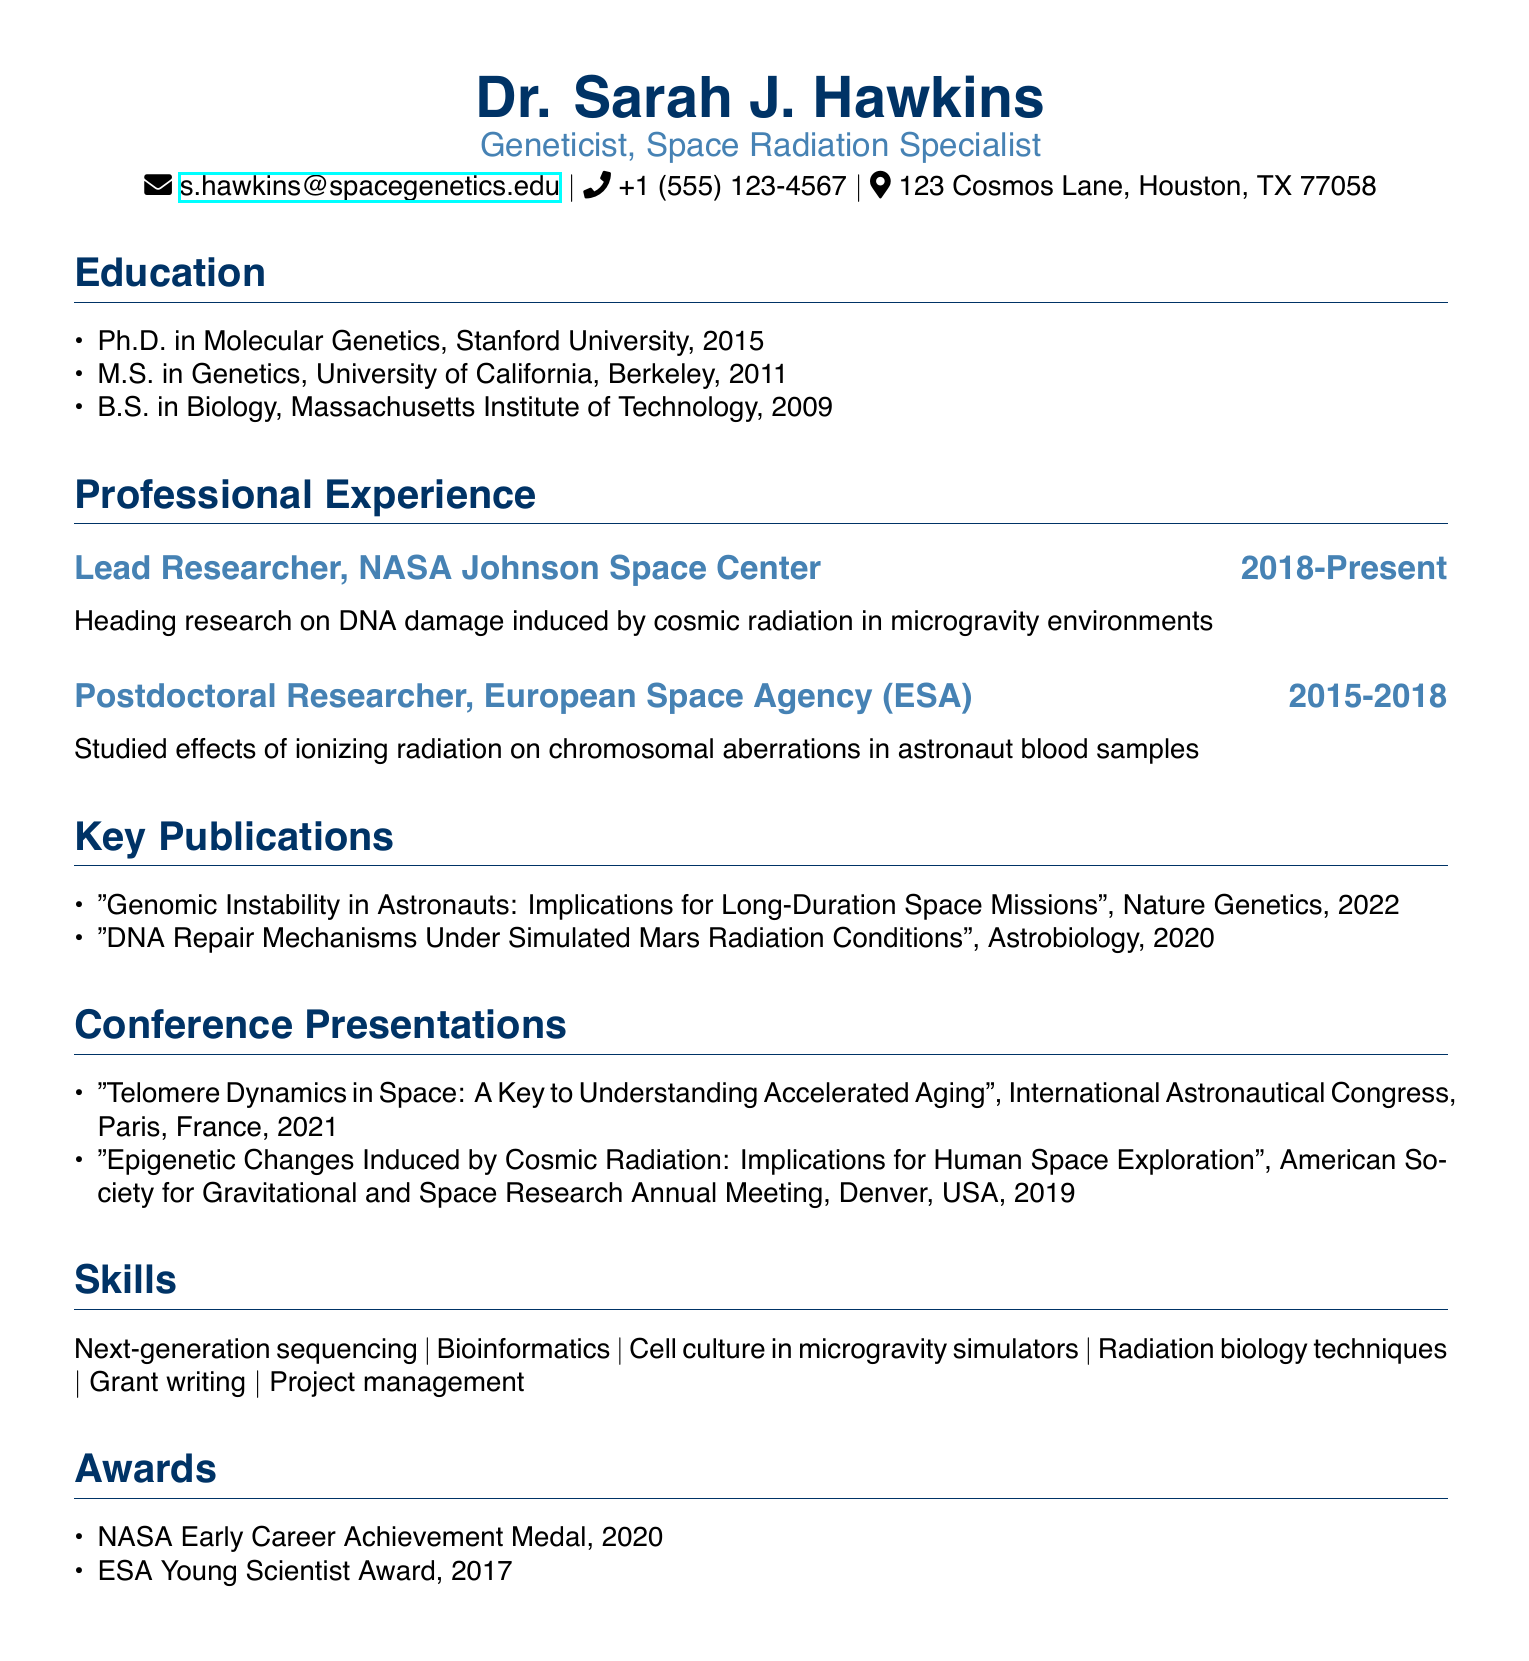What is the name of the lead researcher? The lead researcher is Dr. Sarah J. Hawkins, as stated at the top of the document.
Answer: Dr. Sarah J. Hawkins Which degree was obtained from Stanford University? The degree obtained from Stanford University was a Ph.D. in Molecular Genetics.
Answer: Ph.D. in Molecular Genetics What is the title of the publication in Nature Genetics? The title of the publication in Nature Genetics is "Genomic Instability in Astronauts: Implications for Long-Duration Space Missions."
Answer: "Genomic Instability in Astronauts: Implications for Long-Duration Space Missions" In which year did Dr. Hawkins receive the NASA Early Career Achievement Medal? The NASA Early Career Achievement Medal was received in 2020, as listed under the awards section.
Answer: 2020 How many conference presentations are listed in the document? The document lists a total of two conference presentations under the relevant section.
Answer: 2 What role did Dr. Hawkins hold at the European Space Agency? Dr. Hawkins served as a Postdoctoral Researcher at the European Space Agency.
Answer: Postdoctoral Researcher Where is Dr. Hawkins currently employed? Dr. Hawkins is currently employed at NASA Johnson Space Center.
Answer: NASA Johnson Space Center Which skill is associated with working in a space environment? "Cell culture in microgravity simulators" is a skill associated with working in a space environment.
Answer: Cell culture in microgravity simulators 